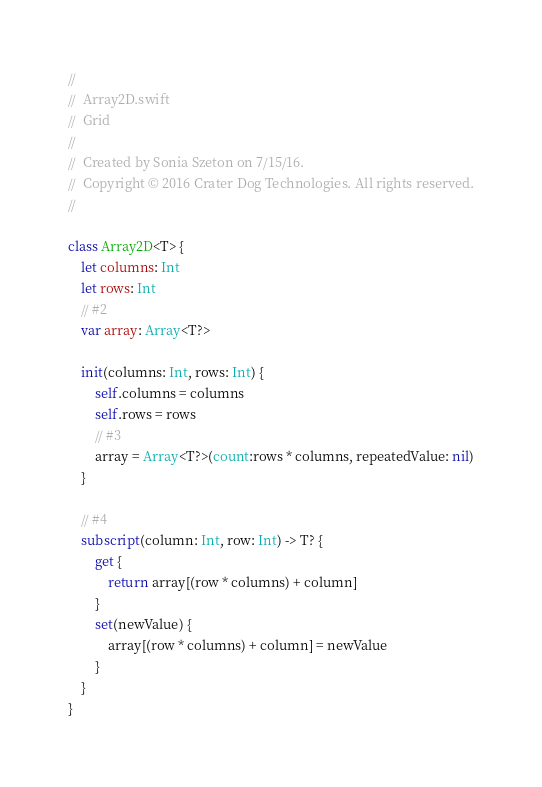Convert code to text. <code><loc_0><loc_0><loc_500><loc_500><_Swift_>//
//  Array2D.swift
//  Grid
//
//  Created by Sonia Szeton on 7/15/16.
//  Copyright © 2016 Crater Dog Technologies. All rights reserved.
//

class Array2D<T> {
    let columns: Int
    let rows: Int
    // #2
    var array: Array<T?>
    
    init(columns: Int, rows: Int) {
        self.columns = columns
        self.rows = rows
        // #3
        array = Array<T?>(count:rows * columns, repeatedValue: nil)
    }
    
    // #4
    subscript(column: Int, row: Int) -> T? {
        get {
            return array[(row * columns) + column]
        }
        set(newValue) {
            array[(row * columns) + column] = newValue
        }
    }
}</code> 